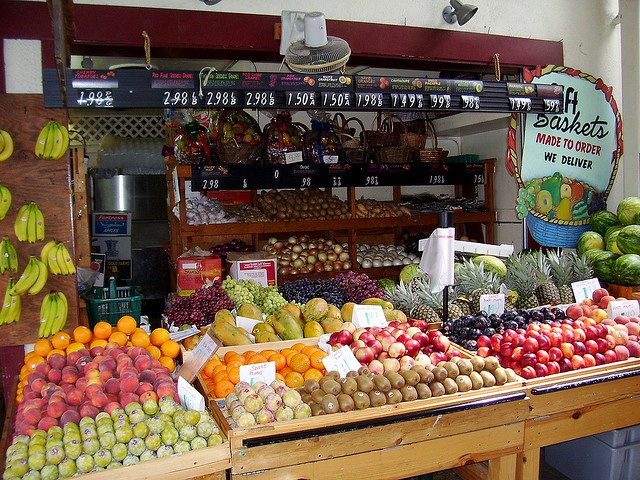Describe the objects in this image and their specific colors. I can see apple in black, salmon, and brown tones, apple in black, brown, white, and salmon tones, apple in black, lightpink, brown, white, and tan tones, orange in black, orange, red, and brown tones, and orange in black, orange, brown, and maroon tones in this image. 